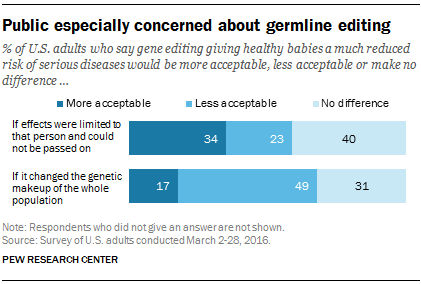Highlight a few significant elements in this photo. The upper "No difference" bar has a value of 0.4. The median of all the bars is greater than the smallest "less acceptable" bar. 